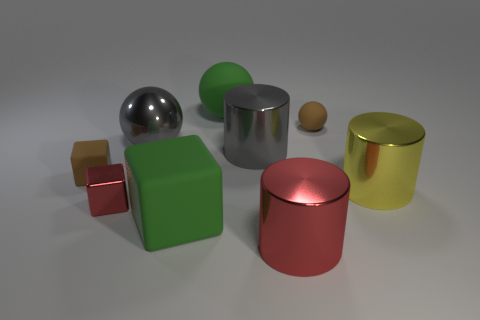Add 1 cyan matte spheres. How many objects exist? 10 Subtract all cylinders. How many objects are left? 6 Add 6 tiny blocks. How many tiny blocks are left? 8 Add 6 cubes. How many cubes exist? 9 Subtract 1 brown blocks. How many objects are left? 8 Subtract all small green rubber blocks. Subtract all large yellow cylinders. How many objects are left? 8 